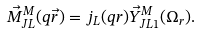<formula> <loc_0><loc_0><loc_500><loc_500>\vec { M } _ { J L } ^ { M } ( q \vec { r } ) = j _ { L } ( q r ) \vec { Y } _ { J L 1 } ^ { M } ( \Omega _ { r } ) .</formula> 